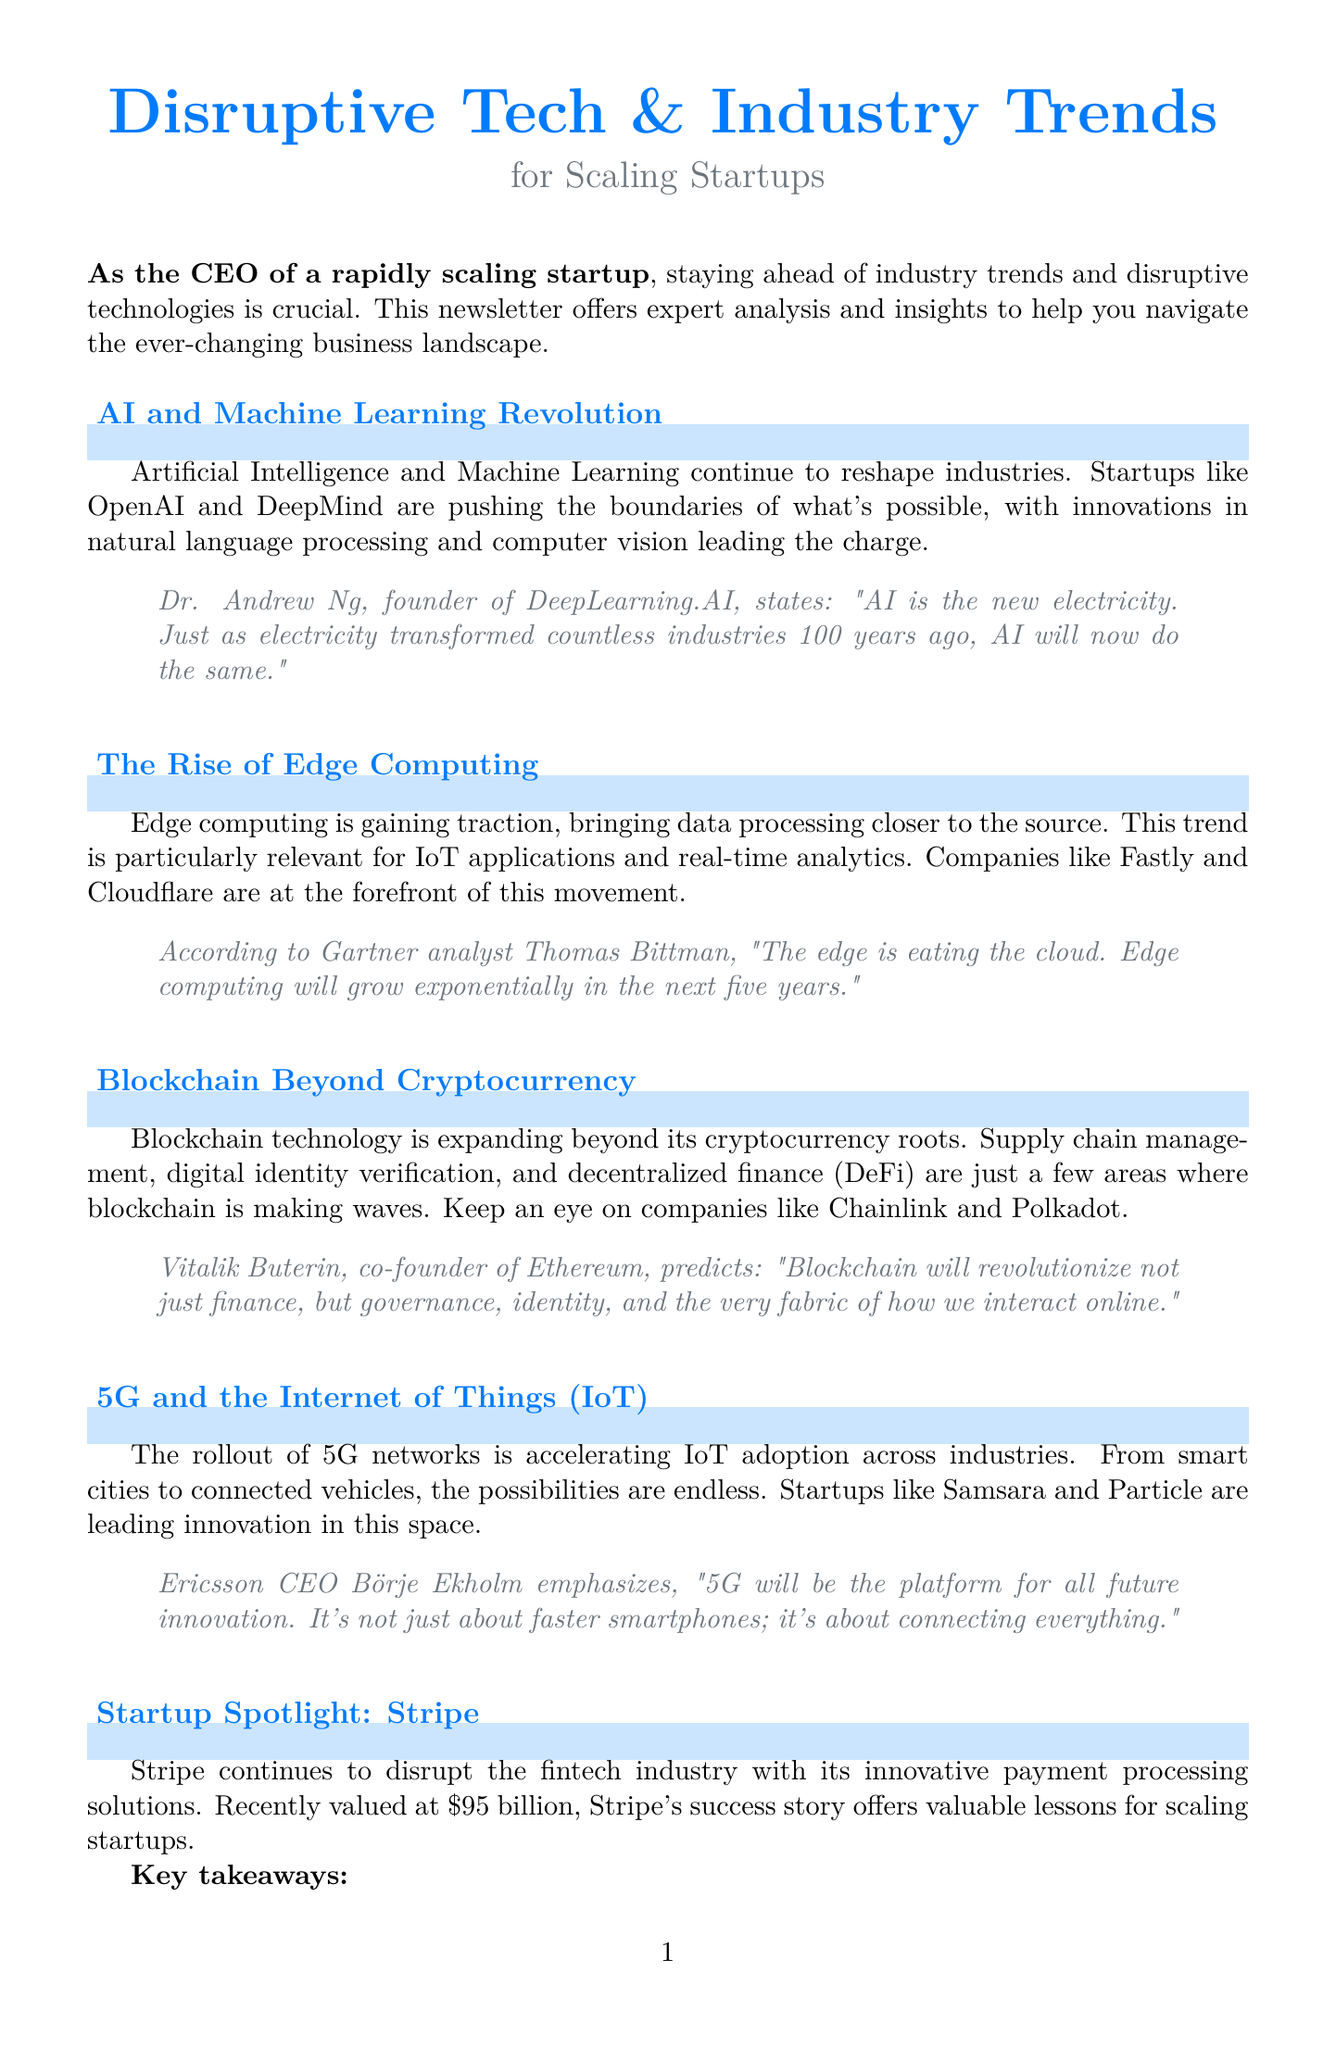What is the title of the newsletter? The title of the newsletter is presented at the beginning of the document.
Answer: Disruptive Tech & Industry Trends for Scaling Startups Who is the CEO of DeepLearning.AI? The document includes a quote from the founder of DeepLearning.AI, identifying him.
Answer: Dr. Andrew Ng What technology is said to be "the new electricity"? This phrase is attributed to the impact of a specific technology in the document.
Answer: AI Which company is spotlighted in the newsletter? The newsletter features a specific startup that is creating waves in the fintech industry.
Answer: Stripe What is the predicted growth trend of edge computing in the next five years? A statement from a Gartner analyst highlights the expected growth trend of edge computing.
Answer: Exponentially What lesson does Stripe's success story offer for scaling startups? The newsletter provides key takeaways under the startup spotlight section.
Answer: Focus on developer-friendly products What type of technology is being revolutionized beyond cryptocurrency according to the document? The newsletter discusses applications of a specific technology beyond its original context.
Answer: Blockchain What is the registration website for the CEO roundtable? The call to action provides a specific URL for registration.
Answer: startupceosummit.com 